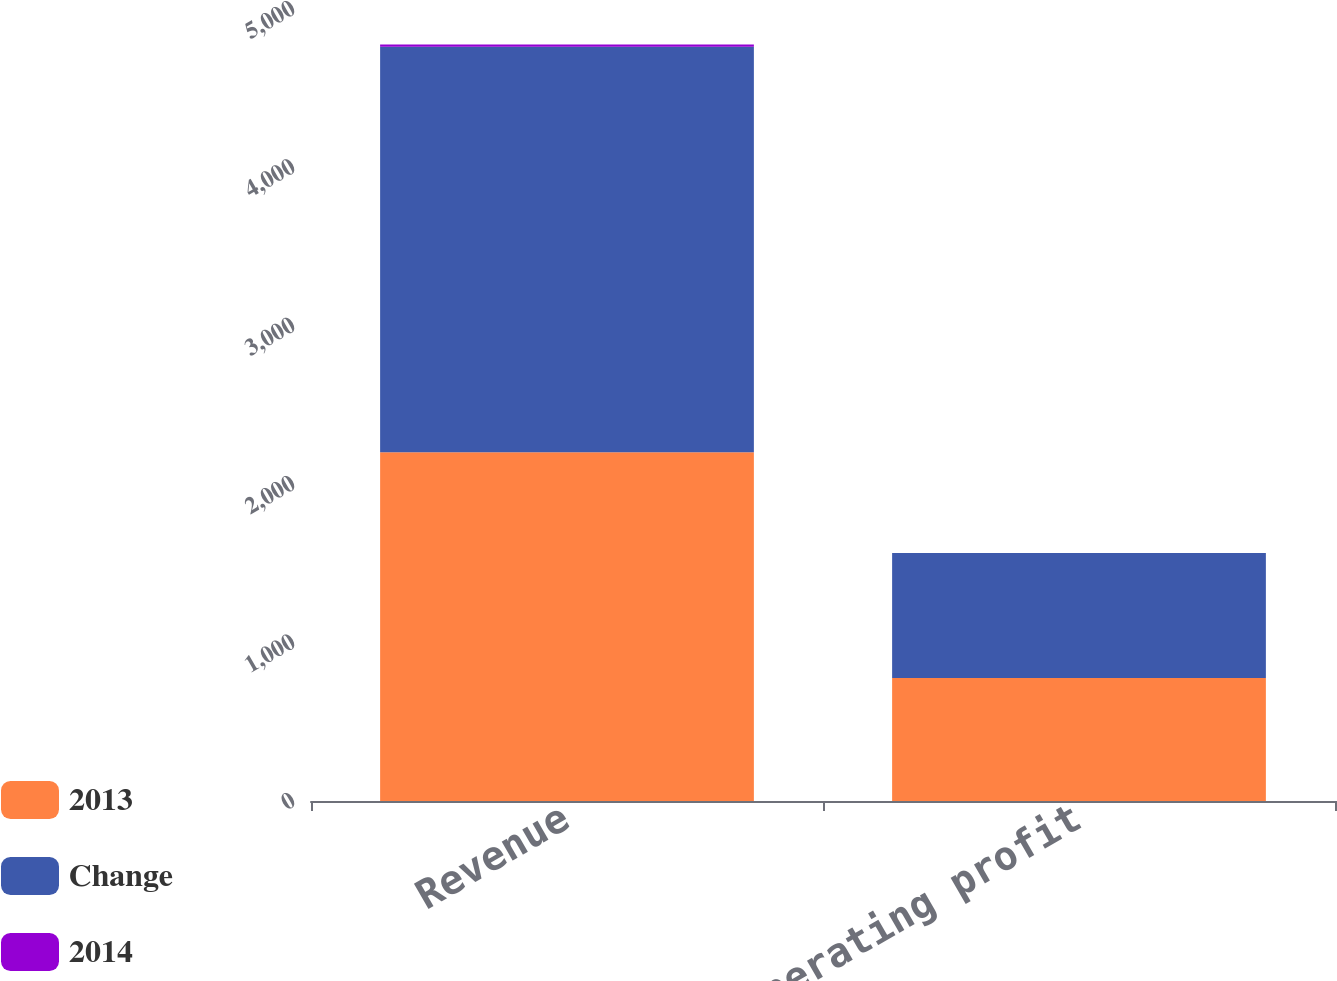Convert chart. <chart><loc_0><loc_0><loc_500><loc_500><stacked_bar_chart><ecel><fcel>Revenue<fcel>Operating profit<nl><fcel>2013<fcel>2201<fcel>777<nl><fcel>Change<fcel>2561<fcel>788<nl><fcel>2014<fcel>14<fcel>1<nl></chart> 